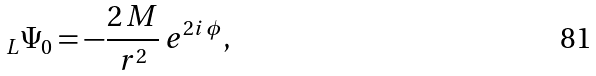<formula> <loc_0><loc_0><loc_500><loc_500>_ { L } \Psi _ { 0 } = - \frac { 2 \, M } { r ^ { 2 } } \, e ^ { 2 i \, \phi } ,</formula> 